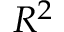Convert formula to latex. <formula><loc_0><loc_0><loc_500><loc_500>R ^ { 2 }</formula> 